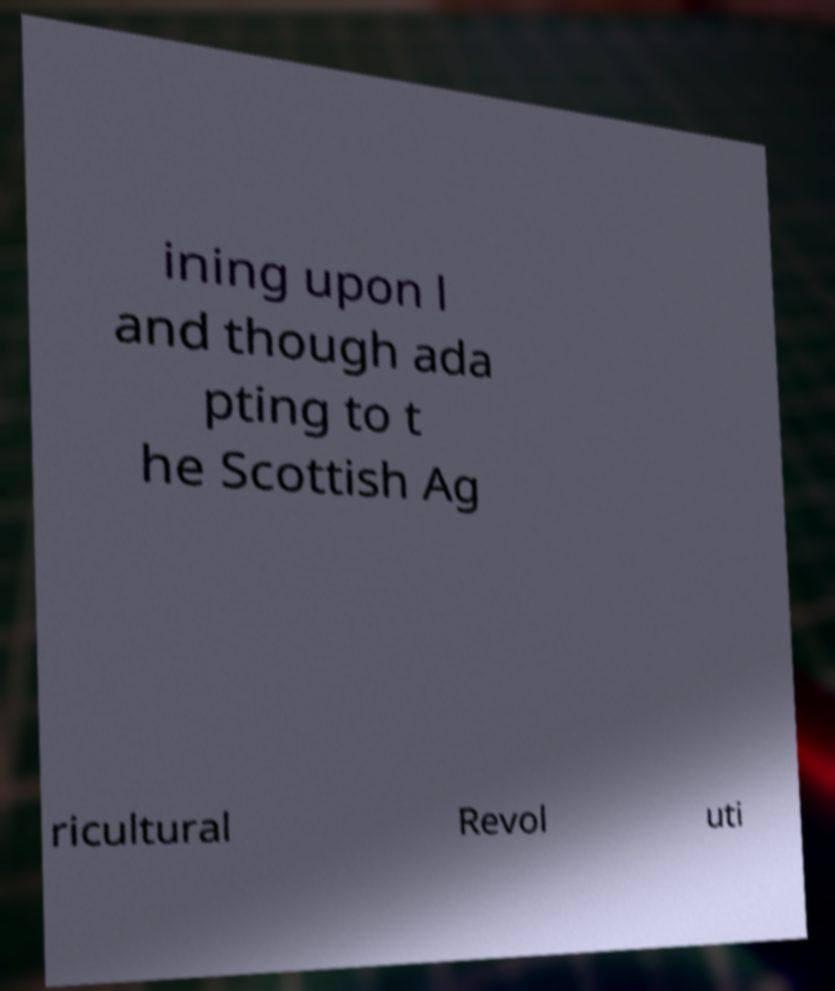For documentation purposes, I need the text within this image transcribed. Could you provide that? ining upon l and though ada pting to t he Scottish Ag ricultural Revol uti 